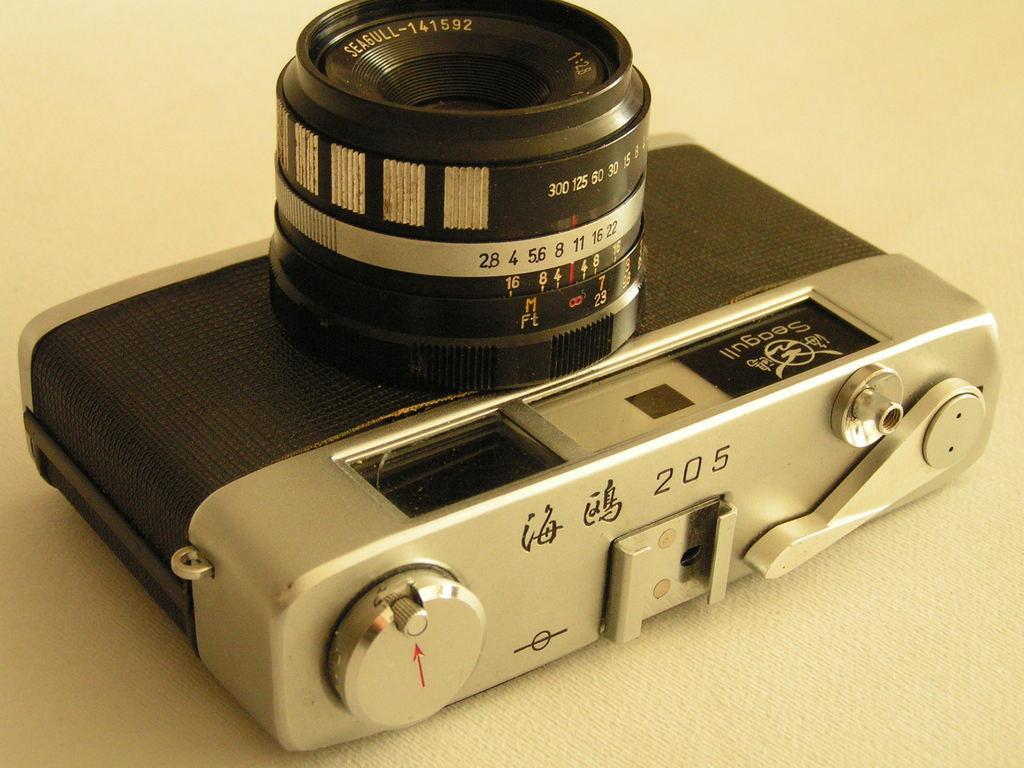Describe this image in one or two sentences. In this picture we can see a camera. 